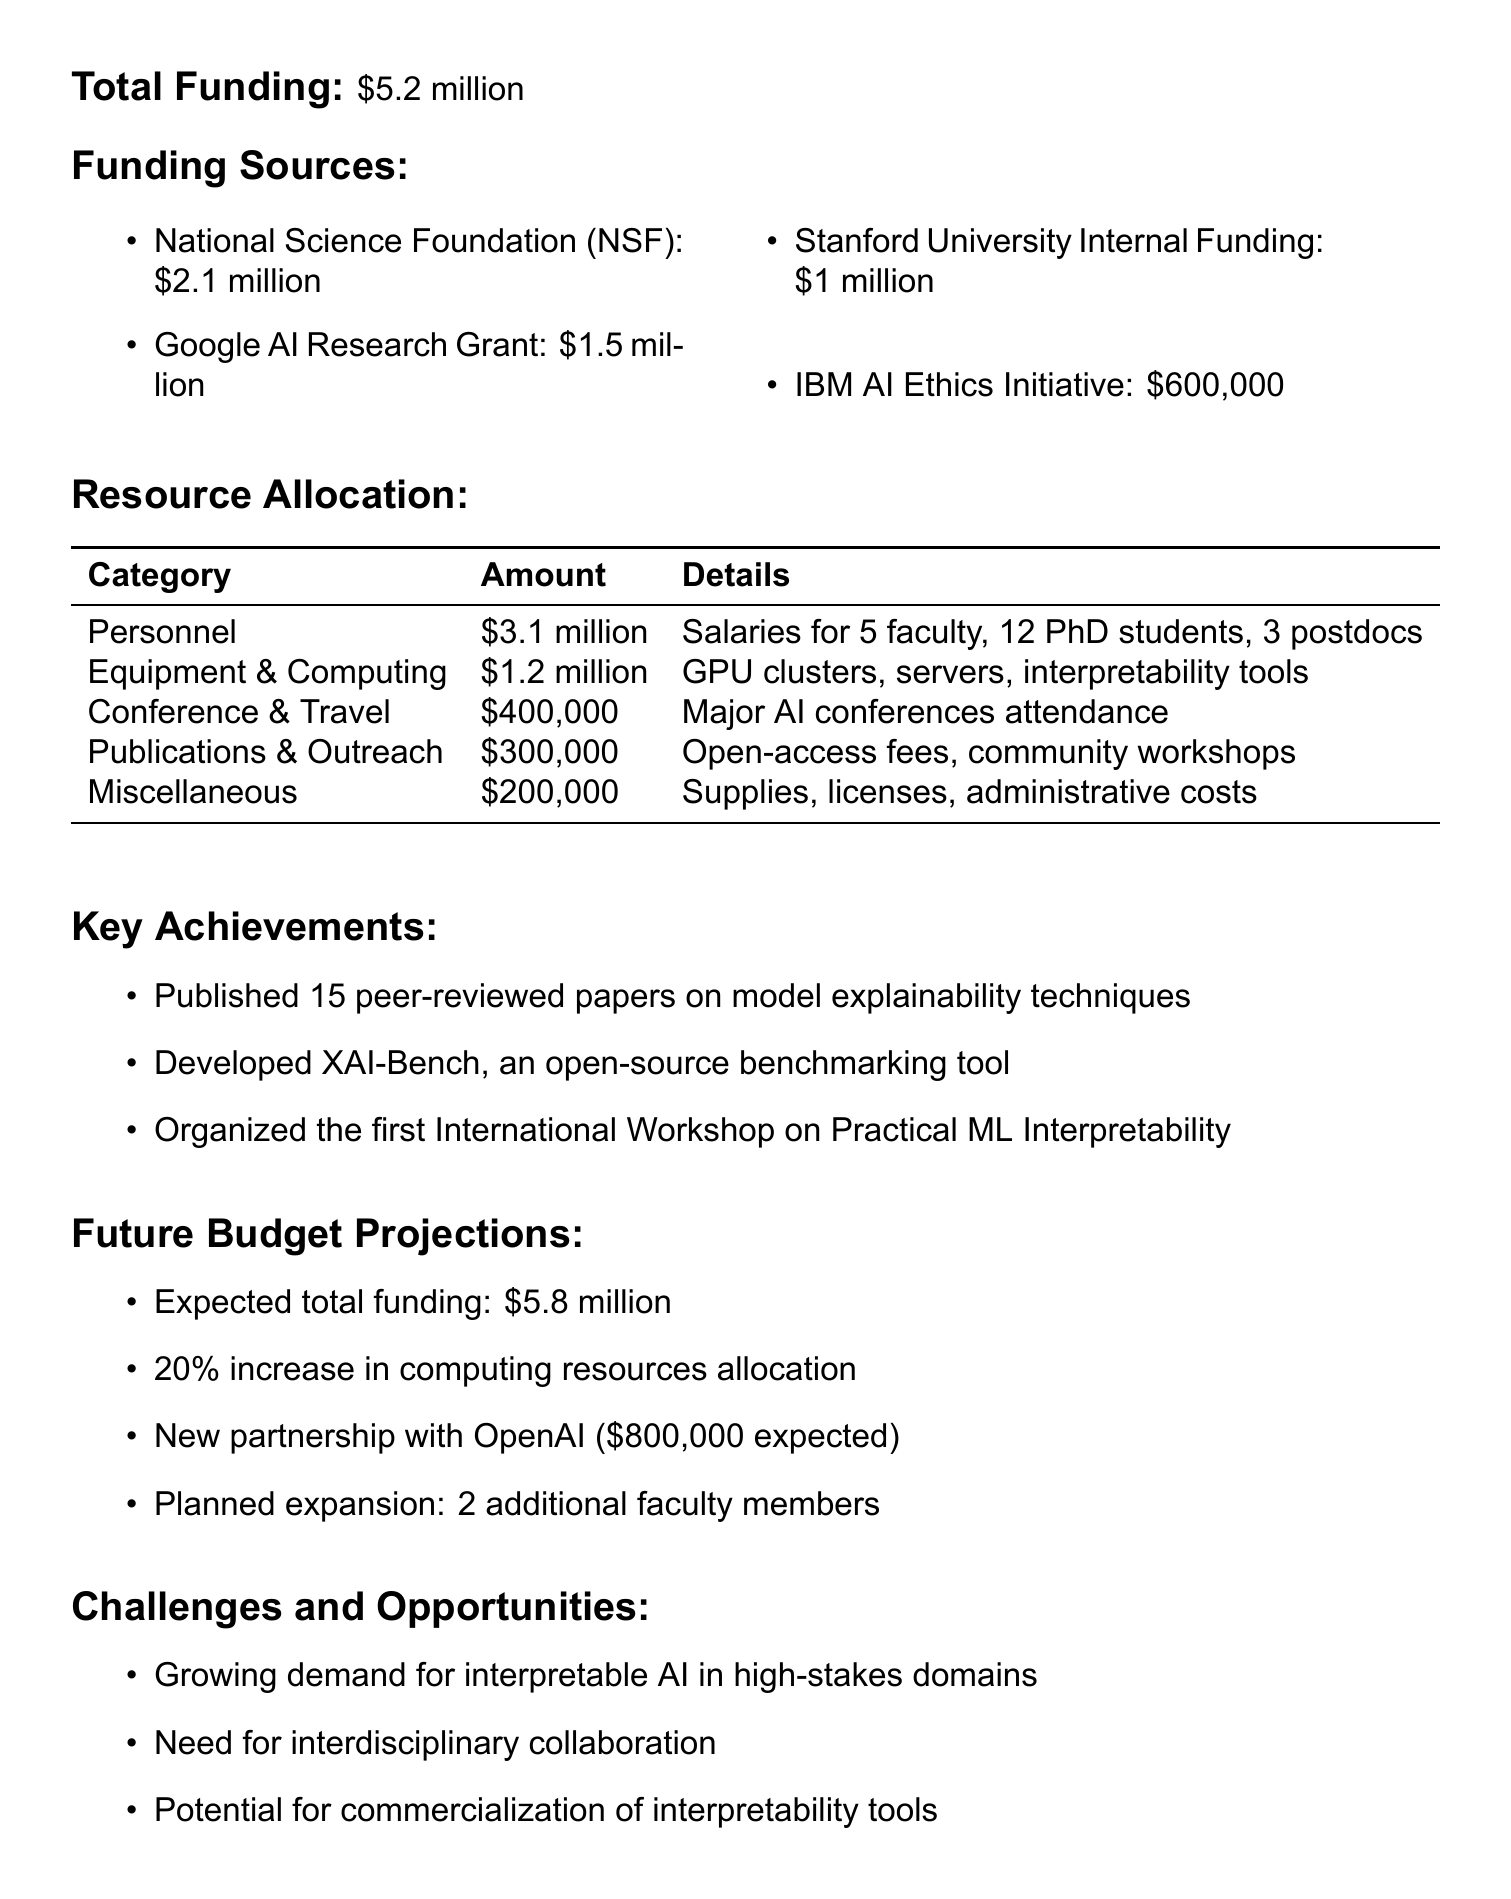What is the total funding for the lab? The total funding is directly stated in the document.
Answer: $5.2 million How much is allocated for Personnel? The amount allocated for Personnel is provided in the resource allocation section.
Answer: $3.1 million What is the funding source from Google? The funding source and the corresponding amount can be found in the funding sources section.
Answer: $1.5 million What is one key achievement of the lab? The document lists several key achievements, one of which is specifically stated.
Answer: Published 15 peer-reviewed papers on model explainability techniques What is the expected total funding for the next fiscal year? The future budget projections section provides expectations for next year’s funding.
Answer: $5.8 million How many faculty members are planned to be added? The document states plans for future faculty expansion in the budget projections section.
Answer: 2 additional faculty members What challenge is mentioned regarding the demand for AI? The challenges and opportunities section addresses specific challenges the lab faces.
Answer: Growing demand for interpretable AI in high-stakes domains What is the total amount allocated for Equipment and Computing Resources? This information is found in the resource allocation table of the document.
Answer: $1.2 million Which organization is providing funding alongside Stanford University? The funding sources section lists the organizations providing funding to the lab.
Answer: Google AI Research Grant 